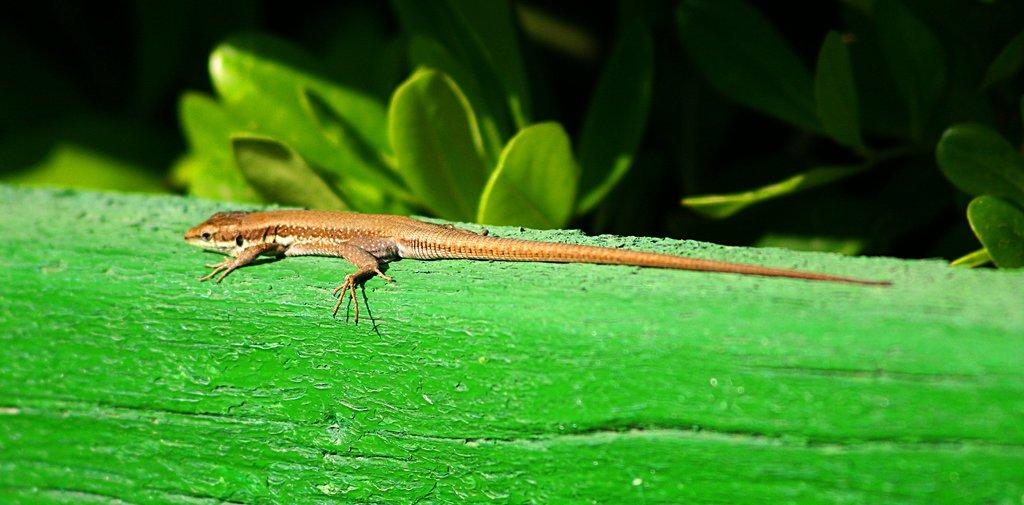What type of vegetation can be seen in the image? There are leaves in the image. What animal is present in the image? There is a lizard in the image. On what surface is the lizard located? The lizard is on a green surface. What type of fog can be seen surrounding the lizard in the image? There is no fog present in the image; it only features leaves and a lizard on a green surface. 